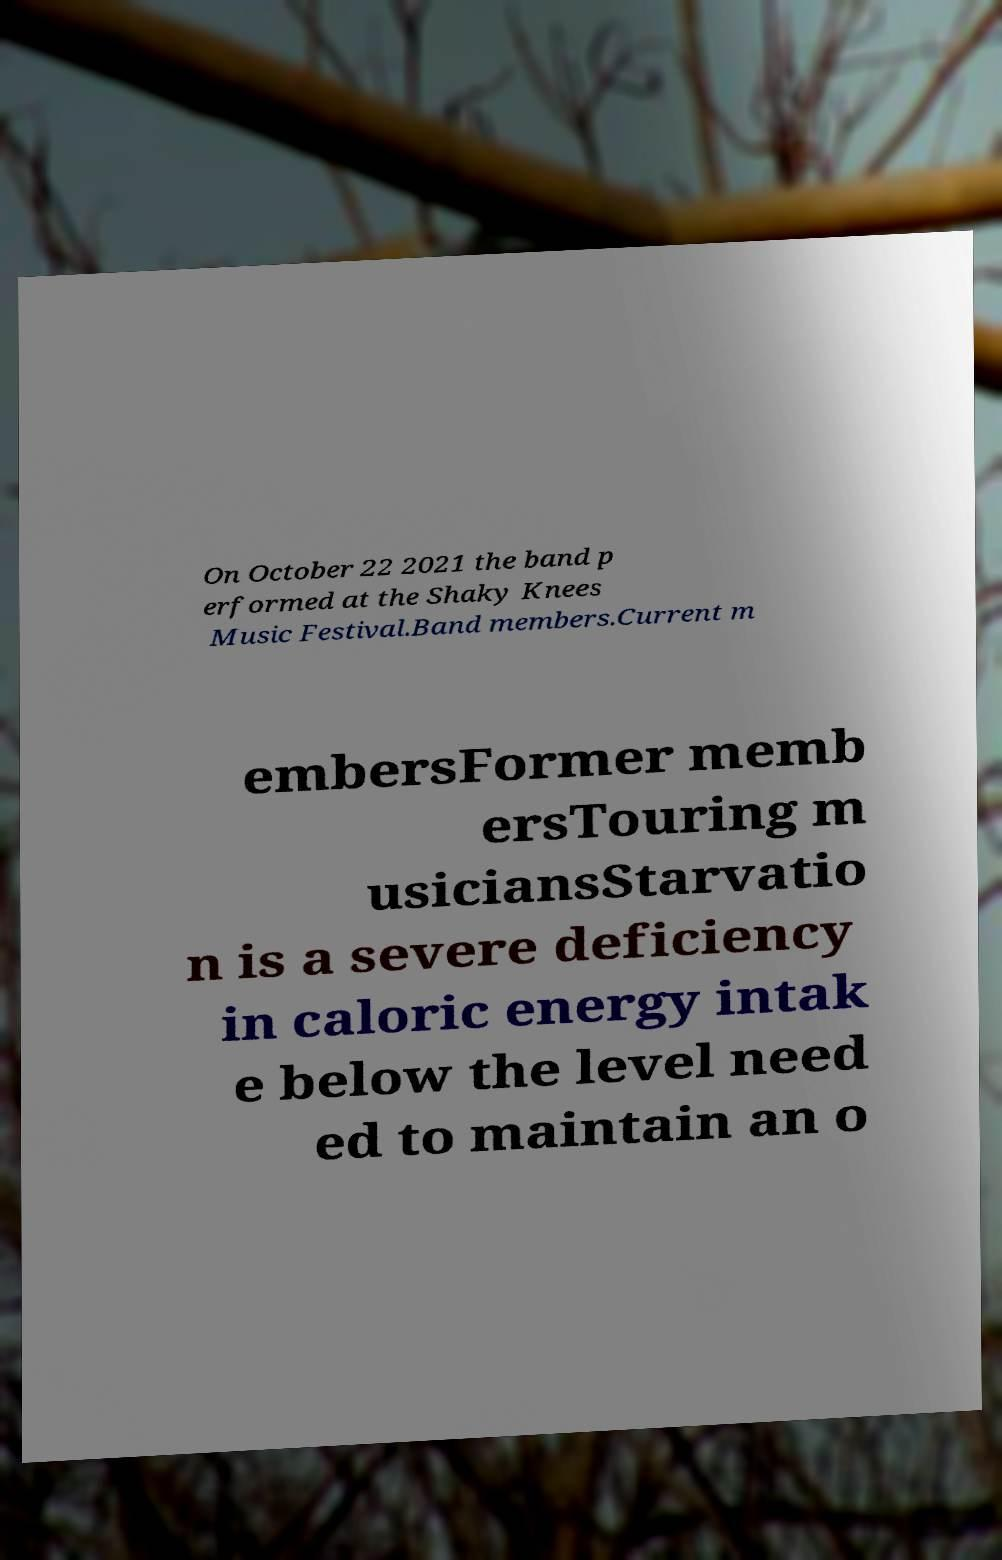Please identify and transcribe the text found in this image. On October 22 2021 the band p erformed at the Shaky Knees Music Festival.Band members.Current m embersFormer memb ersTouring m usiciansStarvatio n is a severe deficiency in caloric energy intak e below the level need ed to maintain an o 